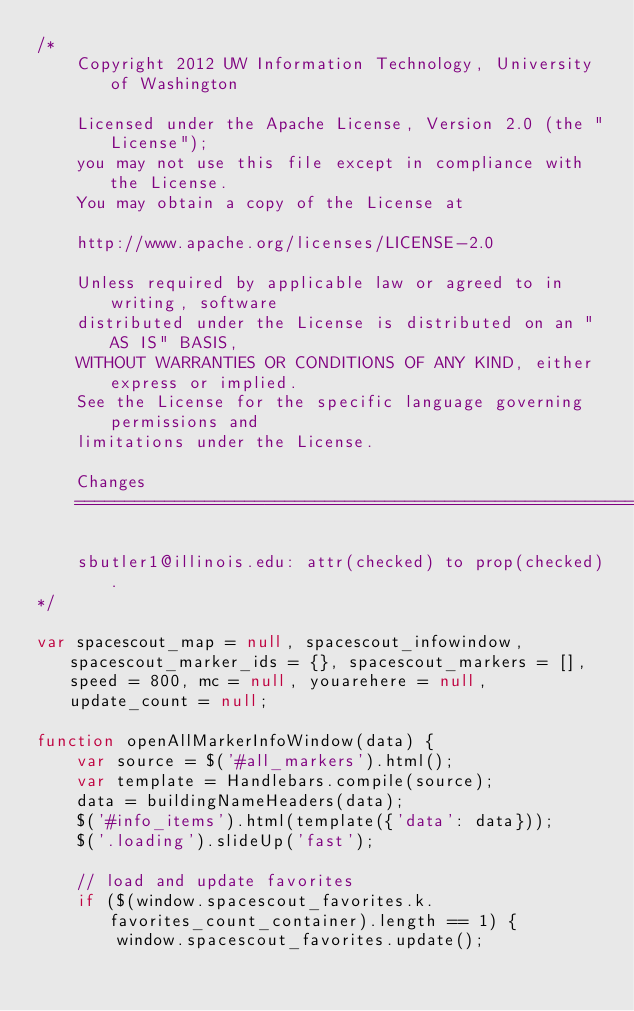Convert code to text. <code><loc_0><loc_0><loc_500><loc_500><_JavaScript_>/*
    Copyright 2012 UW Information Technology, University of Washington

    Licensed under the Apache License, Version 2.0 (the "License");
    you may not use this file except in compliance with the License.
    You may obtain a copy of the License at

    http://www.apache.org/licenses/LICENSE-2.0

    Unless required by applicable law or agreed to in writing, software
    distributed under the License is distributed on an "AS IS" BASIS,
    WITHOUT WARRANTIES OR CONDITIONS OF ANY KIND, either express or implied.
    See the License for the specific language governing permissions and
    limitations under the License.

    Changes
    =================================================================

    sbutler1@illinois.edu: attr(checked) to prop(checked).
*/

var spacescout_map = null, spacescout_infowindow, spacescout_marker_ids = {}, spacescout_markers = [], speed = 800, mc = null, youarehere = null, update_count = null;

function openAllMarkerInfoWindow(data) {
    var source = $('#all_markers').html();
    var template = Handlebars.compile(source);
    data = buildingNameHeaders(data);
    $('#info_items').html(template({'data': data}));
    $('.loading').slideUp('fast');

    // load and update favorites
    if ($(window.spacescout_favorites.k.favorites_count_container).length == 1) {
        window.spacescout_favorites.update();
</code> 